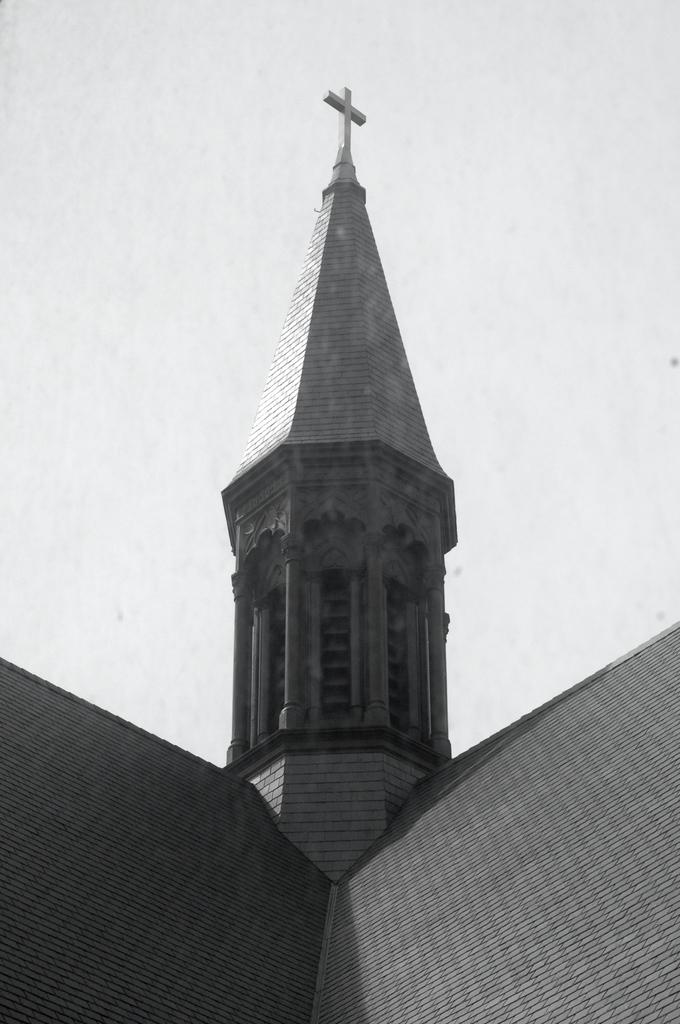What is the color scheme of the image? The image is black and white. What type of structures can be seen in the image? There are roofs visible in the image. What religious symbol is present on a tower in the image? There is a cross symbol on a tower in the image. What is visible in the background of the image? The sky is visible in the image. What type of wax can be seen melting on the gate in the image? There is no gate or wax present in the image; it features roofs, a cross symbol, and a black and white color scheme. 